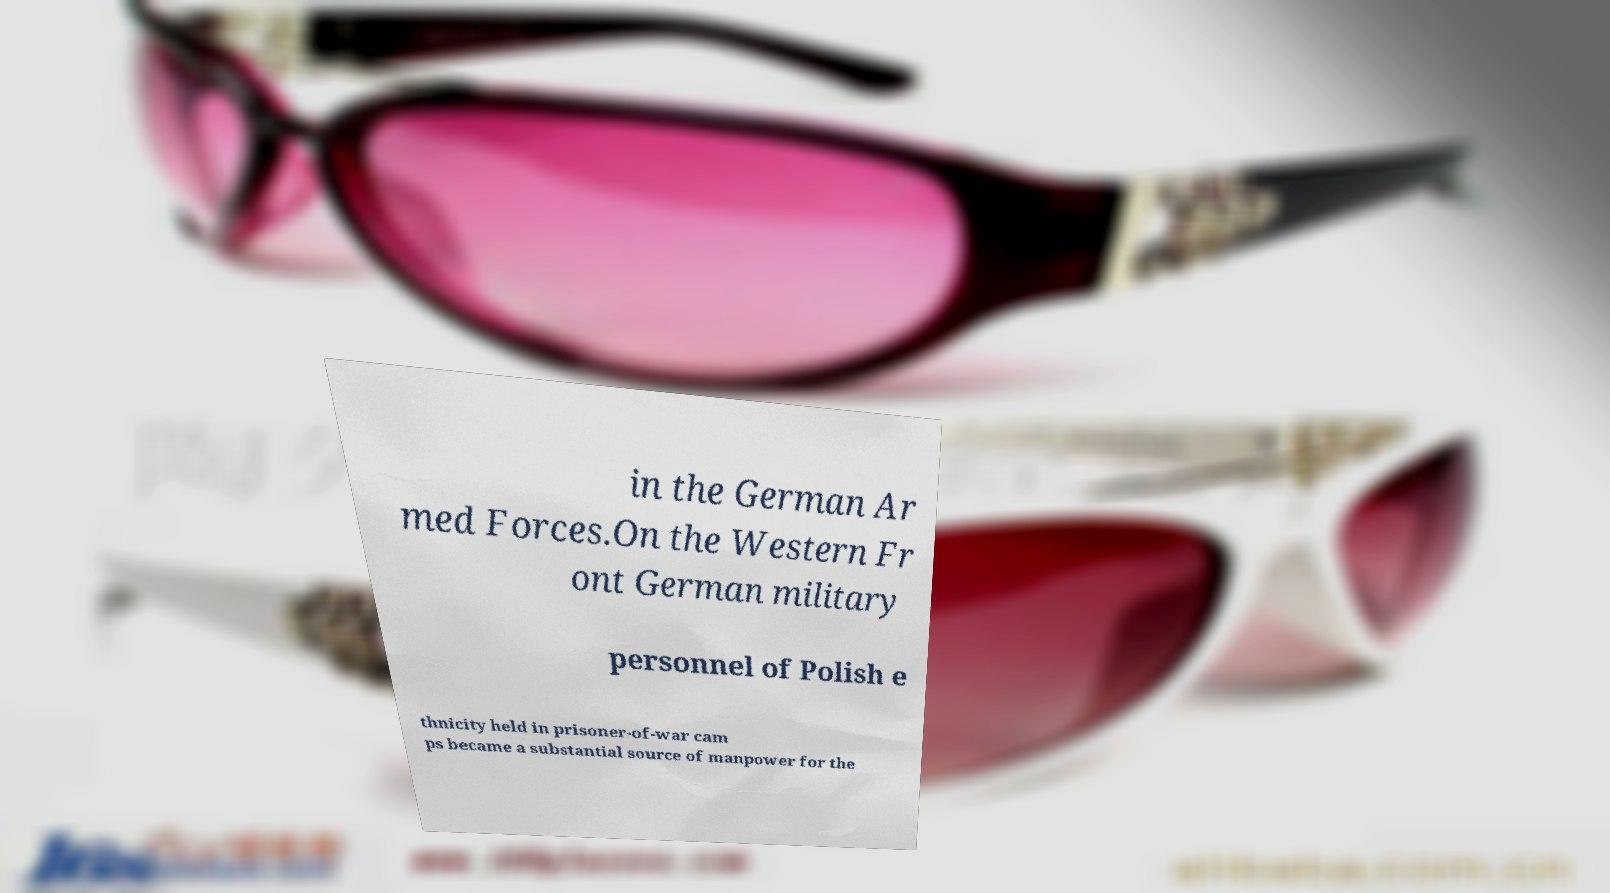Could you assist in decoding the text presented in this image and type it out clearly? in the German Ar med Forces.On the Western Fr ont German military personnel of Polish e thnicity held in prisoner-of-war cam ps became a substantial source of manpower for the 